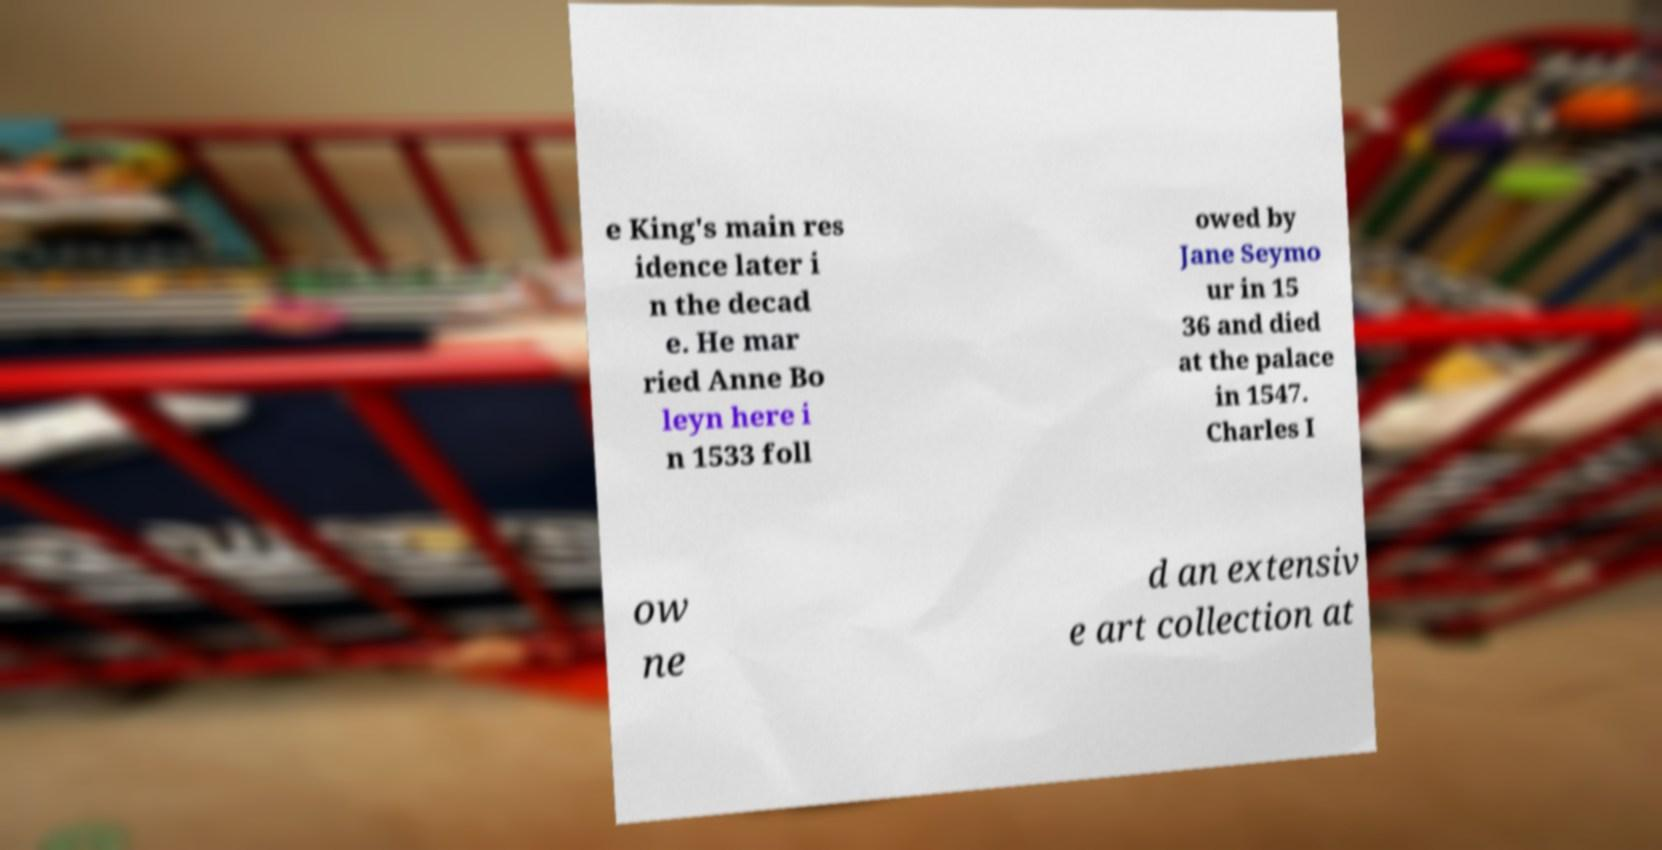There's text embedded in this image that I need extracted. Can you transcribe it verbatim? e King's main res idence later i n the decad e. He mar ried Anne Bo leyn here i n 1533 foll owed by Jane Seymo ur in 15 36 and died at the palace in 1547. Charles I ow ne d an extensiv e art collection at 